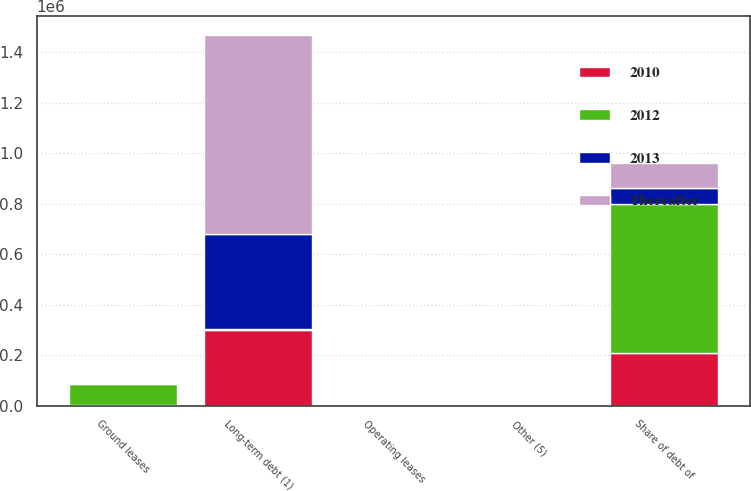Convert chart. <chart><loc_0><loc_0><loc_500><loc_500><stacked_bar_chart><ecel><fcel>Long-term debt (1)<fcel>Share of debt of<fcel>Ground leases<fcel>Operating leases<fcel>Other (5)<nl><fcel>2012<fcel>2076<fcel>591962<fcel>84436<fcel>1297<fcel>1565<nl><fcel>2010<fcel>301079<fcel>207817<fcel>2076<fcel>518<fcel>529<nl><fcel>Thereafter<fcel>789057<fcel>98971<fcel>2090<fcel>364<fcel>223<nl><fcel>2013<fcel>377120<fcel>60784<fcel>1950<fcel>142<fcel>225<nl></chart> 